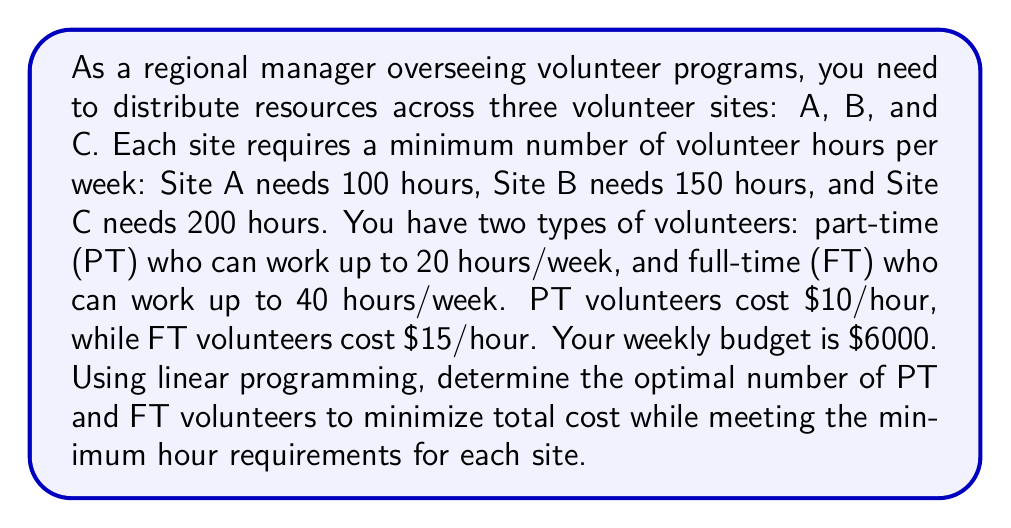Teach me how to tackle this problem. Let's solve this step-by-step using linear programming:

1) Define variables:
   $x$ = number of PT volunteers
   $y$ = number of FT volunteers

2) Objective function (minimize cost):
   $\text{Minimize } Z = 10(20x) + 15(40y) = 200x + 600y$

3) Constraints:
   a) Total hours constraint: $20x + 40y \geq 450$ (sum of minimum hours for all sites)
   b) Budget constraint: $200x + 600y \leq 6000$
   c) Non-negativity: $x \geq 0, y \geq 0$

4) Set up the linear programming problem:
   Minimize $Z = 200x + 600y$
   Subject to:
   $20x + 40y \geq 450$
   $200x + 600y \leq 6000$
   $x \geq 0, y \geq 0$

5) Solve using the graphical method:
   Plot the constraints:
   $20x + 40y = 450$ becomes $y = 11.25 - 0.5x$
   $200x + 600y = 6000$ becomes $y = 10 - \frac{1}{3}x$

6) The feasible region is the area bounded by these lines and the positive x and y axes.

7) The optimal solution will be at one of the corner points of this feasible region. Calculate these points:
   Point 1 (x-intercept of budget line): (30, 0)
   Point 2 (y-intercept of budget line): (0, 10)
   Point 3 (intersection of constraints): (15, 7.5)

8) Evaluate the objective function at each point:
   Z(30, 0) = 6000
   Z(0, 10) = 6000
   Z(15, 7.5) = 3000 + 4500 = 7500

9) The optimal solution is at (15, 7.5), which gives the minimum cost.

Therefore, the optimal distribution is 15 PT volunteers and 7.5 FT volunteers (round up to 8 for practicality).
Answer: 15 PT volunteers, 8 FT volunteers 